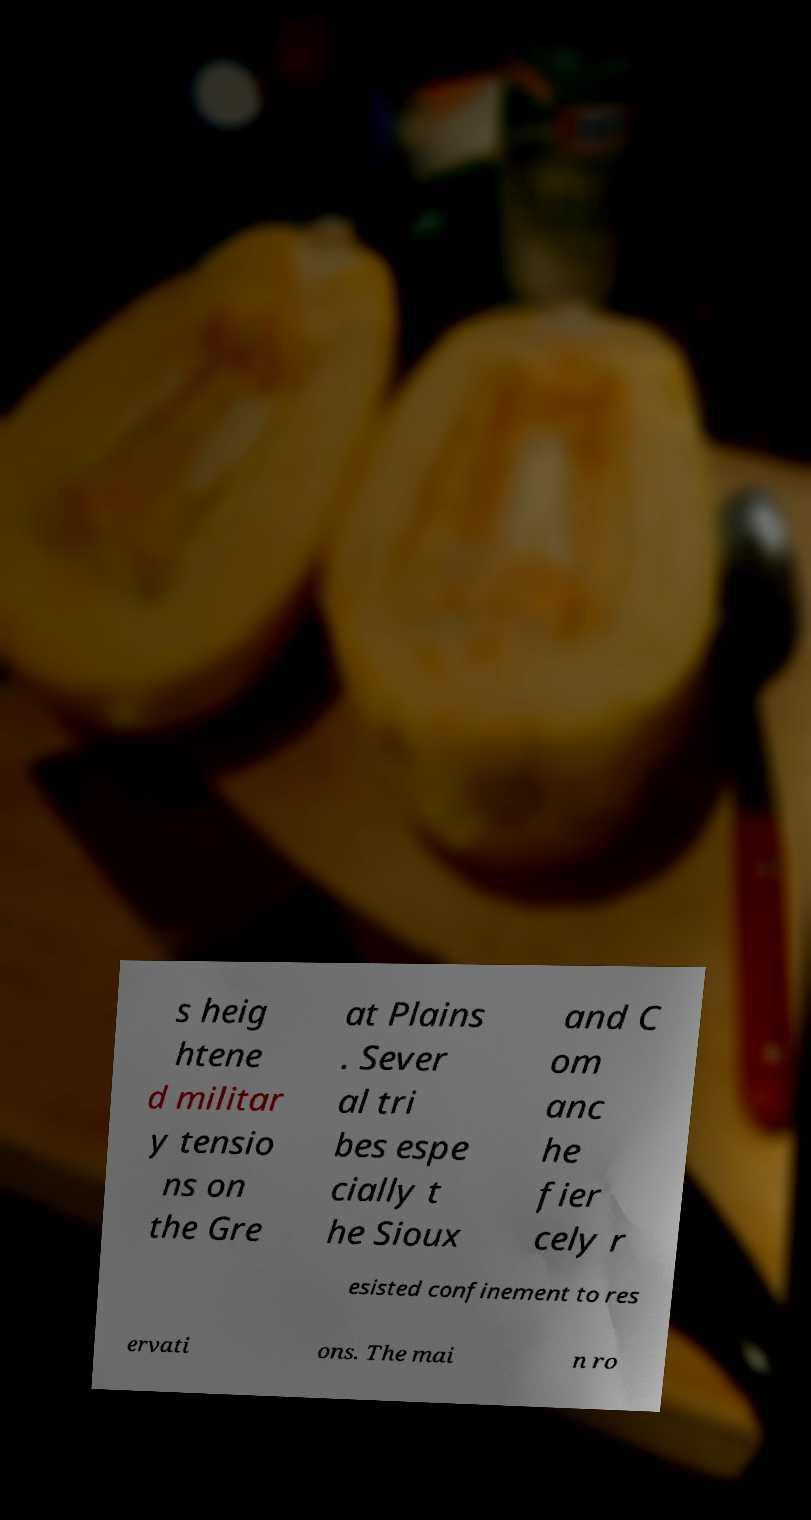I need the written content from this picture converted into text. Can you do that? s heig htene d militar y tensio ns on the Gre at Plains . Sever al tri bes espe cially t he Sioux and C om anc he fier cely r esisted confinement to res ervati ons. The mai n ro 